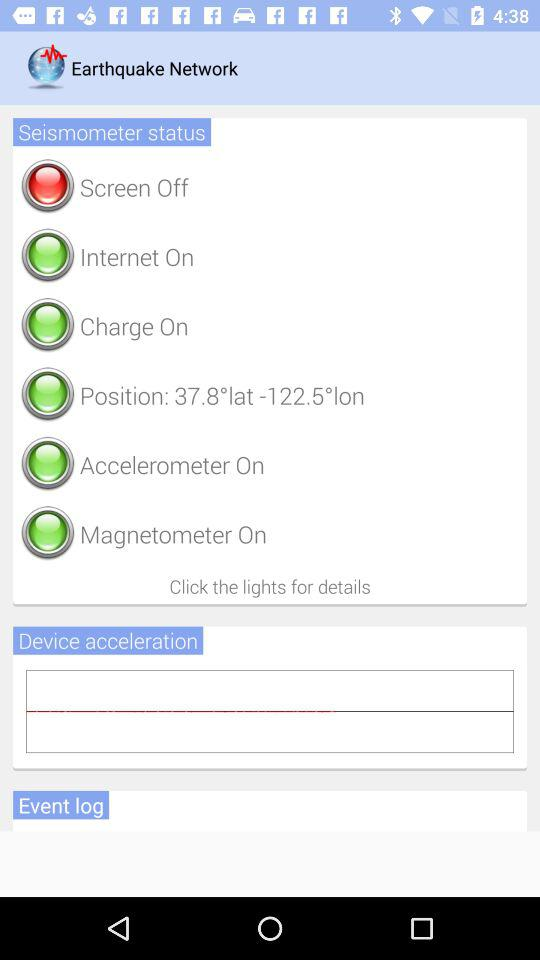Is the internet on or off? The internet is on. 